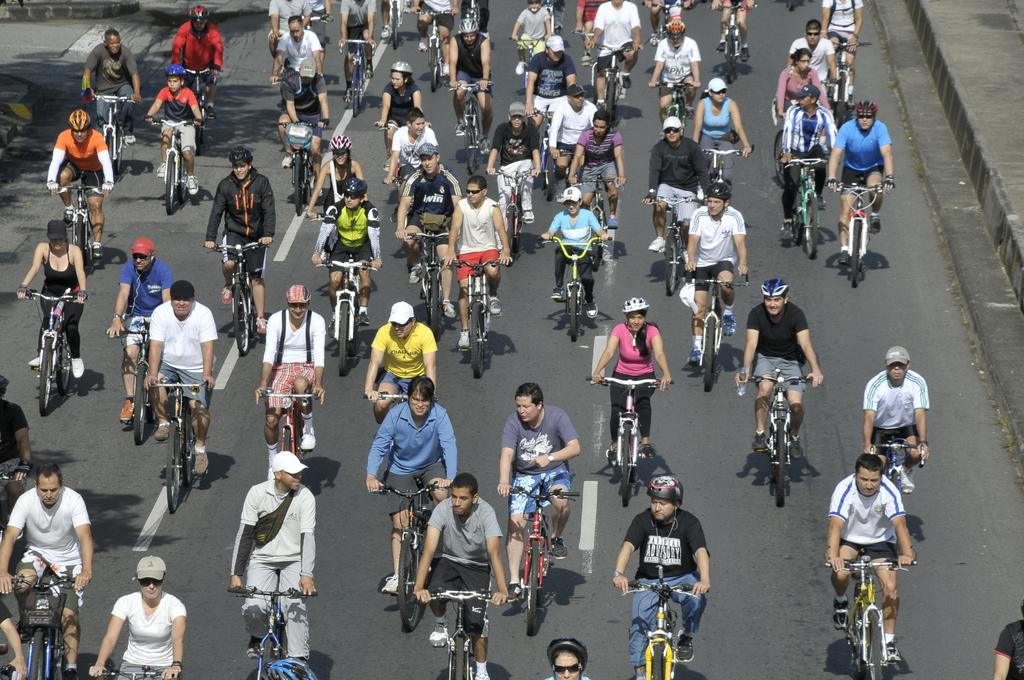How many people are in the image? There are persons in the image. What are the persons doing in the image? The persons are riding bicycles. Where are the bicycles located? The bicycles are on a road. What type of board can be seen being rubbed by the persons in the image? There is no board present in the image, and the persons are not rubbing anything. 